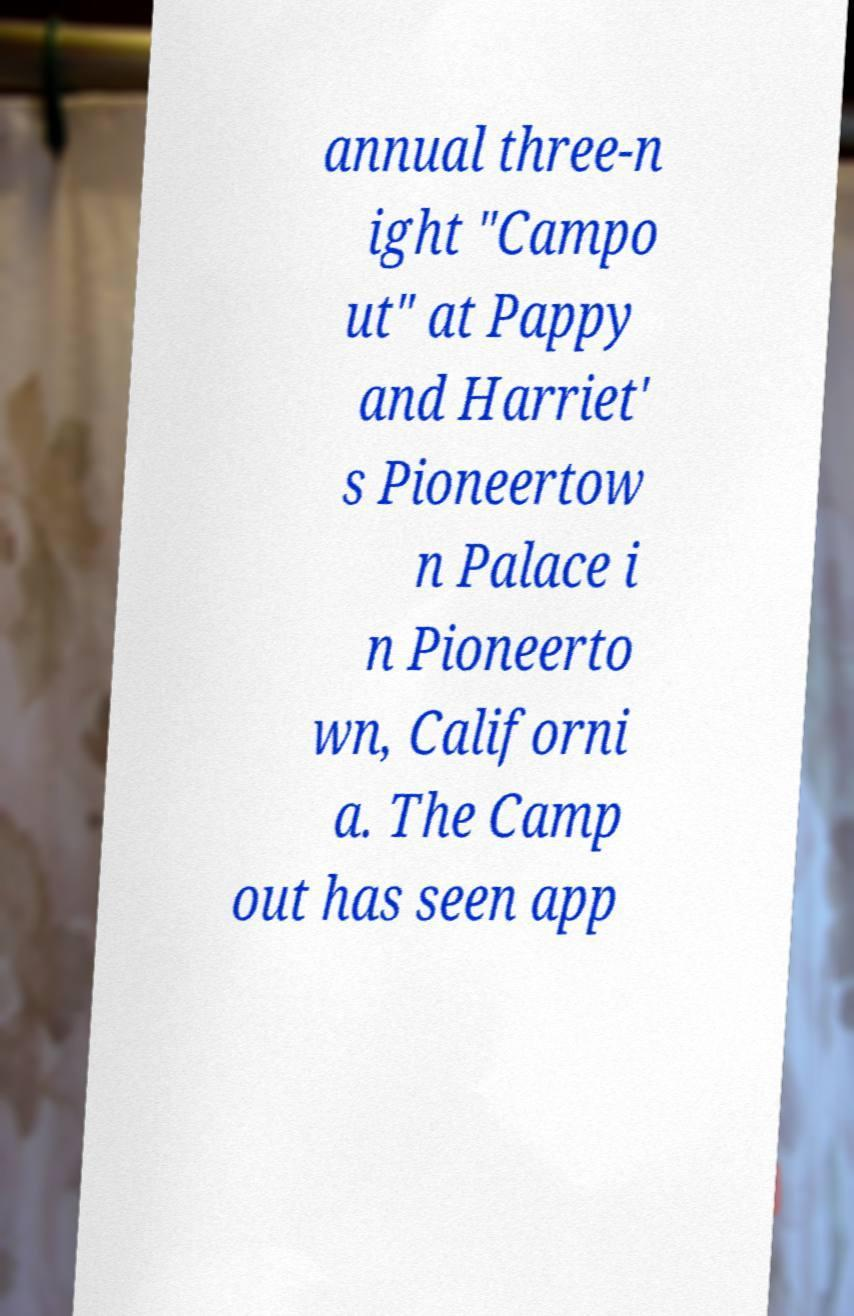Please read and relay the text visible in this image. What does it say? annual three-n ight "Campo ut" at Pappy and Harriet' s Pioneertow n Palace i n Pioneerto wn, Californi a. The Camp out has seen app 